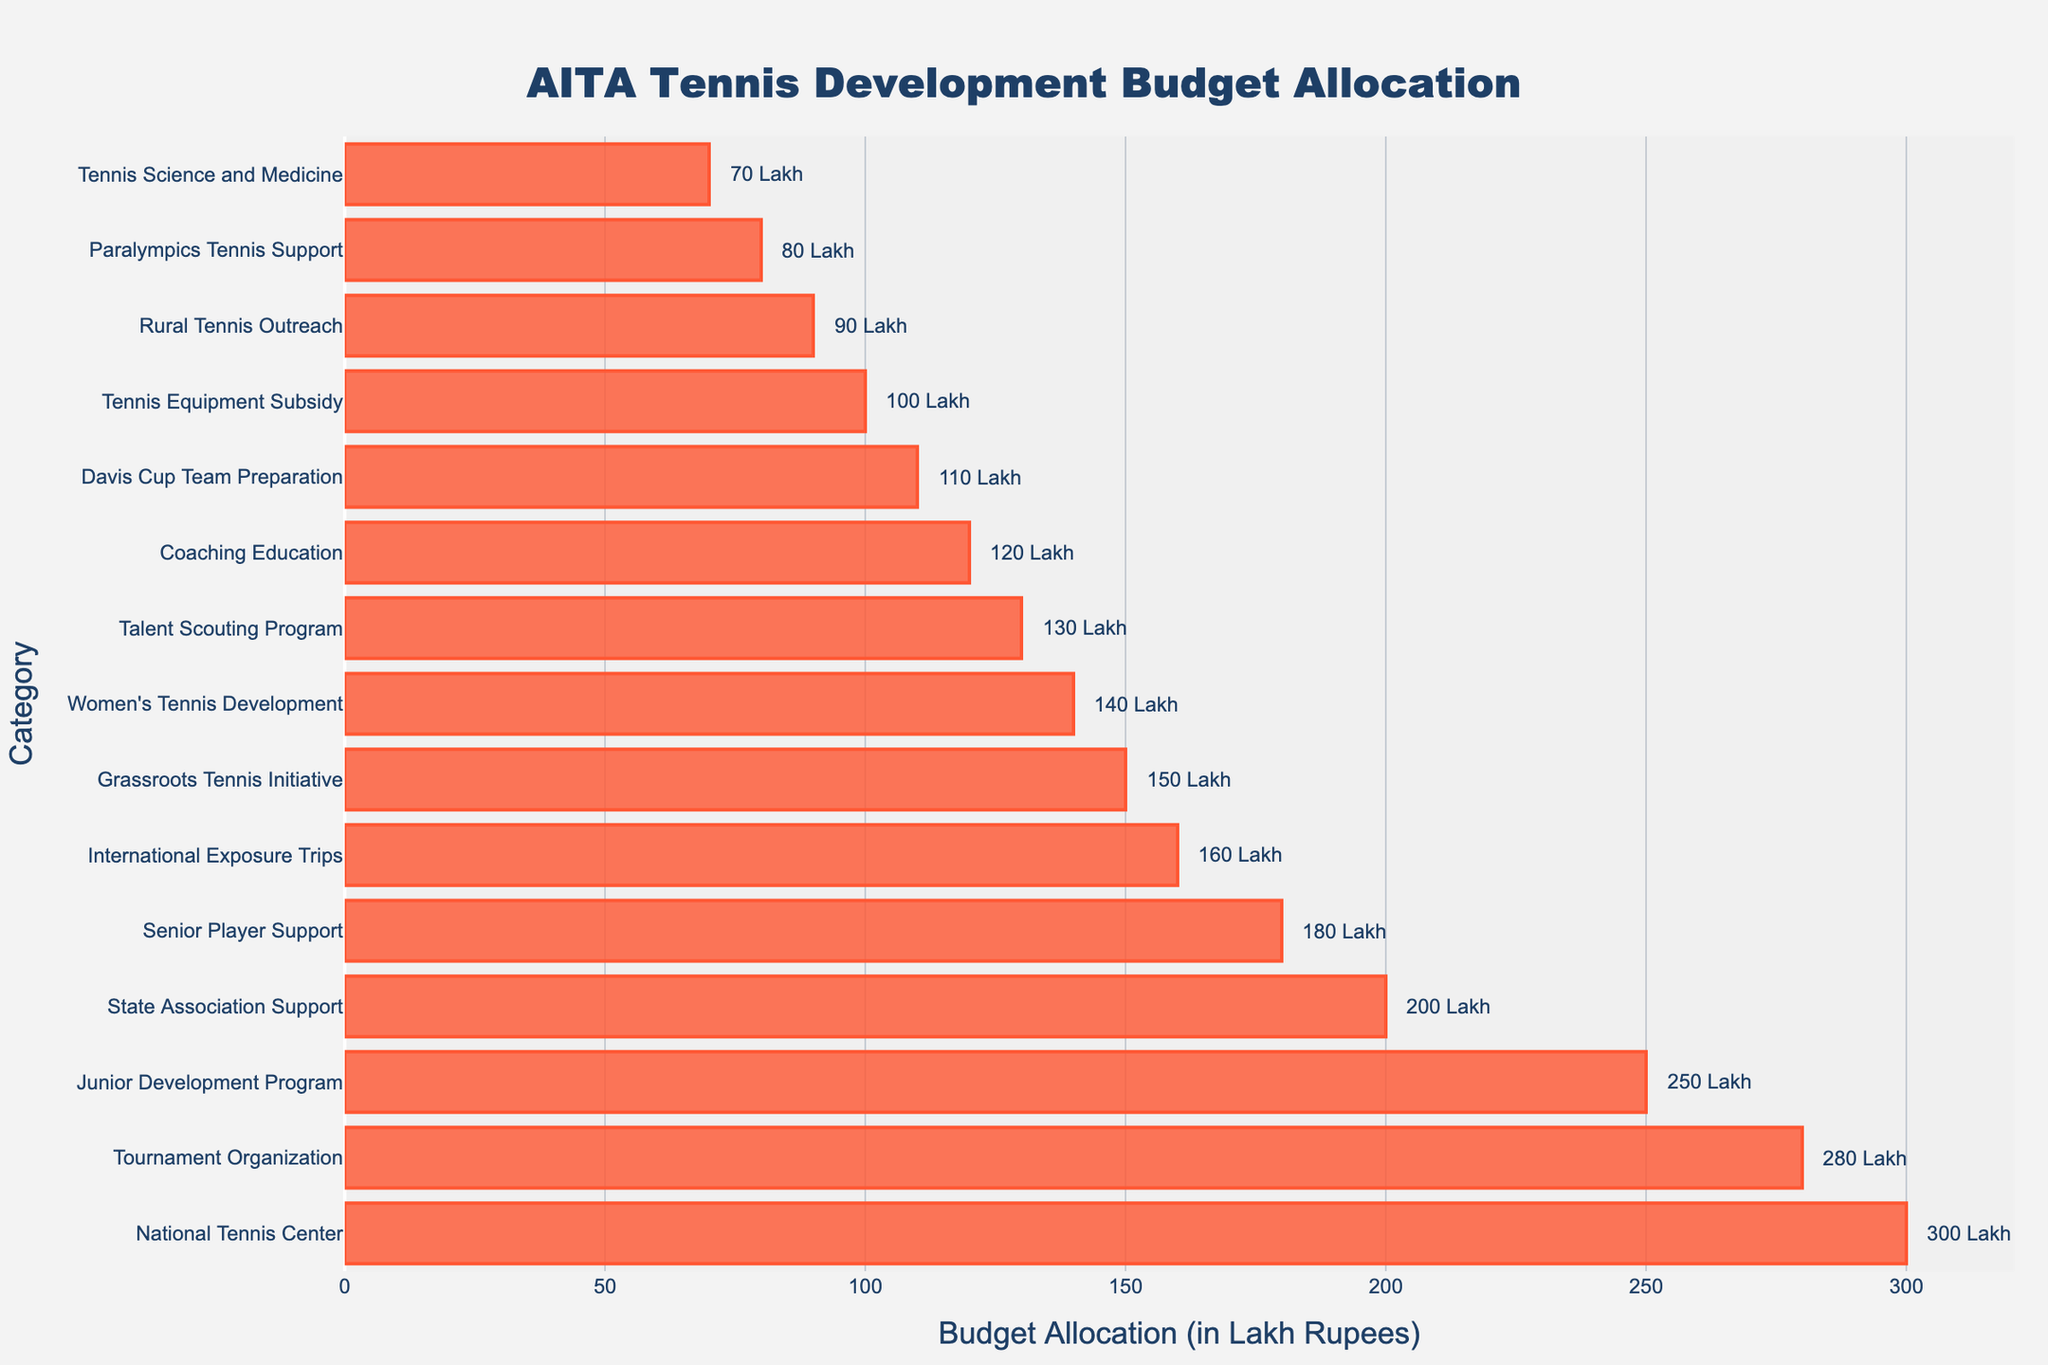Which category has the highest budget allocation? The category with the highest budget allocation is the one with the longest red bar extending furthest to the right. Looking at the figure, this is the National Tennis Center.
Answer: National Tennis Center What is the budget allocation for the Talent Scouting Program? To find the budget for the Talent Scouting Program, locate the category on the y-axis and trace the corresponding bar to its length on the x-axis. The annotation indicates 130 Lakh Rupees.
Answer: 130 Lakh Rupees How much more is allocated to Tournament Organization compared to Coaching Education? First, find the budget allocation for Tournament Organization which is 280 Lakh Rupees. Then find the budget allocation for Coaching Education which is 120 Lakh Rupees. Subtract the latter from the former: 280 - 120 = 160 Lakh Rupees.
Answer: 160 Lakh Rupees Which category has a higher budget, Women's Tennis Development or International Exposure Trips? Compare the lengths of the bars for both categories. Women's Tennis Development has a budget of 140 Lakh Rupees, while International Exposure Trips have a budget of 160 Lakh Rupees. The bar for International Exposure Trips is longer.
Answer: International Exposure Trips What is the combined budget allocation for Junior Development Program and State Association Support? The budget for the Junior Development Program is 250 Lakh Rupees, and for State Association Support, it's 200 Lakh Rupees. Adding these together: 250 + 200 = 450 Lakh Rupees.
Answer: 450 Lakh Rupees Which category has the lowest budget allocation? Identify the category with the shortest bar. The shortest red bar corresponds to Tennis Science and Medicine, which has the lowest budget allocation.
Answer: Tennis Science and Medicine How does the budget allocation for Rural Tennis Outreach compare to Paralympics Tennis Support? Compare the lengths of the bars for Rural Tennis Outreach and Paralympics Tennis Support. Rural Tennis Outreach has a budget of 90 Lakh Rupees and Paralympics Tennis Support has a budget of 80 Lakh Rupees. Therefore, Rural Tennis Outreach has a slightly higher budget.
Answer: Rural Tennis Outreach What is the average budget allocation for the following categories: Grassroots Tennis Initiative, Women's Tennis Development, and Davis Cup Team Preparation? First, note the budgets: Grassroots Tennis Initiative (150 Lakh Rupees), Women's Tennis Development (140 Lakh Rupees), Davis Cup Team Preparation (110 Lakh Rupees). Sum these amounts together: 150 + 140 + 110 = 400 Lakh Rupees. Divide by 3 to obtain the average: 400 / 3 ≈ 133.33 Lakh Rupees.
Answer: 133.33 Lakh Rupees What is the difference in budget allocation between the National Tennis Center and Tennis Equipment Subsidy? The National Tennis Center has a budget of 300 Lakh Rupees, while Tennis Equipment Subsidy has a budget of 100 Lakh Rupees. Subtract the latter from the former: 300 - 100 = 200 Lakh Rupees.
Answer: 200 Lakh Rupees How many categories have a budget allocation greater than 200 Lakh Rupees? Scan the figure for all bars greater than 200 Lakh Rupees on the x-axis. The categories above this threshold are Junior Development Program, National Tennis Center, Tournament Organization, and State Association Support, totaling 4 categories.
Answer: 4 